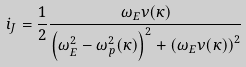Convert formula to latex. <formula><loc_0><loc_0><loc_500><loc_500>i _ { J } = \frac { 1 } { 2 } \frac { \omega _ { E } \nu ( \kappa ) } { \left ( \omega _ { E } ^ { 2 } - \omega _ { p } ^ { 2 } ( \kappa ) \right ) ^ { 2 } + \left ( \omega _ { E } \nu ( \kappa ) \right ) ^ { 2 } }</formula> 